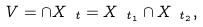Convert formula to latex. <formula><loc_0><loc_0><loc_500><loc_500>V = \cap X _ { \ t } = X _ { \ t _ { 1 } } \cap X _ { \ t _ { 2 } } ,</formula> 